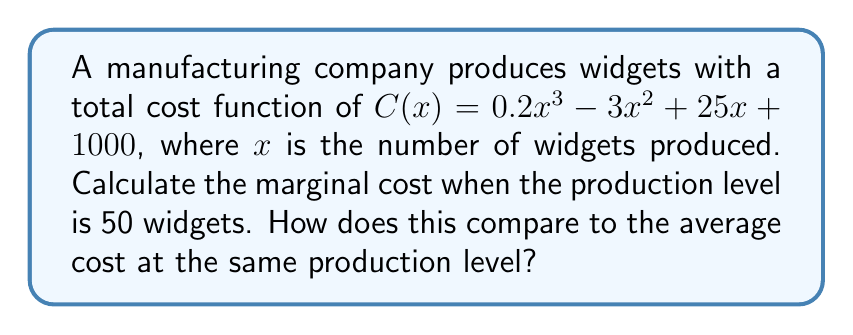Teach me how to tackle this problem. 1. The marginal cost is the derivative of the total cost function:
   $$MC(x) = \frac{d}{dx}C(x) = \frac{d}{dx}(0.2x^3 - 3x^2 + 25x + 1000)$$
   $$MC(x) = 0.6x^2 - 6x + 25$$

2. To find the marginal cost at 50 widgets, substitute $x = 50$:
   $$MC(50) = 0.6(50)^2 - 6(50) + 25$$
   $$MC(50) = 0.6(2500) - 300 + 25$$
   $$MC(50) = 1500 - 300 + 25 = 1225$$

3. For comparison, calculate the average cost at 50 widgets:
   $$AC(x) = \frac{C(x)}{x} = \frac{0.2x^3 - 3x^2 + 25x + 1000}{x}$$
   $$AC(50) = \frac{0.2(50)^3 - 3(50)^2 + 25(50) + 1000}{50}$$
   $$AC(50) = \frac{25000 - 7500 + 1250 + 1000}{50} = \frac{19750}{50} = 395$$

4. The marginal cost (1225) is significantly higher than the average cost (395) at 50 widgets, indicating increasing costs as production increases.
Answer: $MC(50) = 1225$; higher than $AC(50) = 395$ 